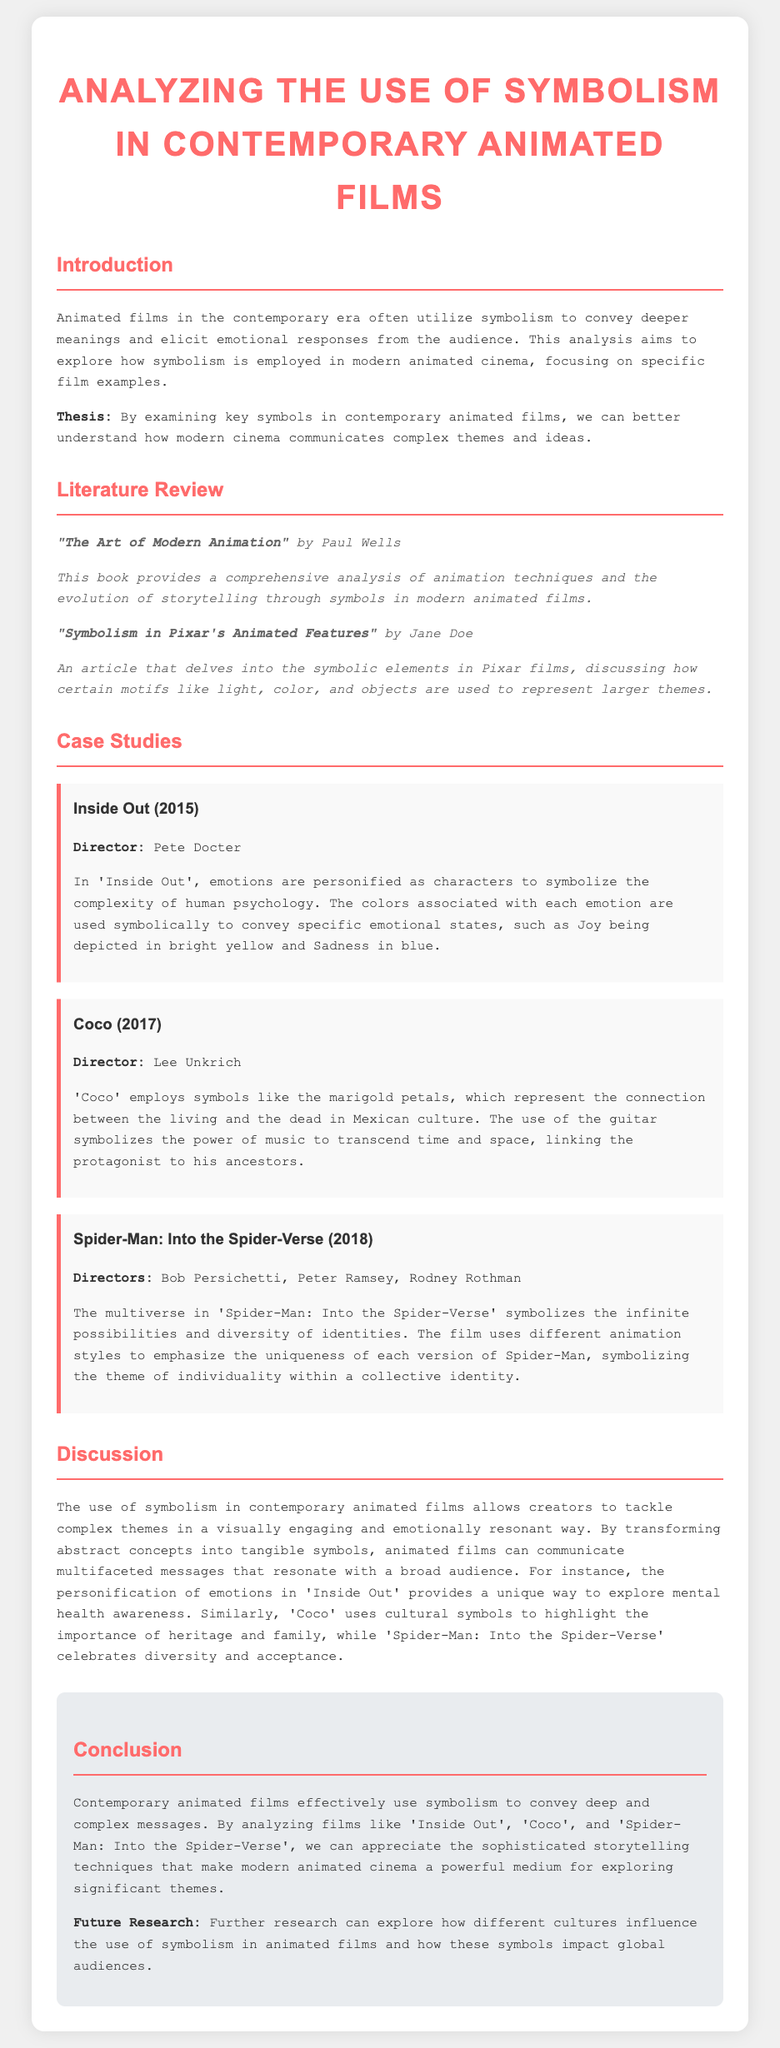What is the title of the report? The title of the report is stated in the document's header, which introduces the main analysis focus.
Answer: Analyzing the Use of Symbolism in Contemporary Animated Films Who is the director of 'Inside Out'? The director's name is mentioned in the case study section detailing the film and its elements.
Answer: Pete Docter What year was 'Coco' released? The release year is included in the specific case study for 'Coco'.
Answer: 2017 What do the marigold petals symbolize in 'Coco'? The document explains that certain symbols in films represent specific cultural meanings.
Answer: Connection between the living and the dead Which two films are compared regarding their exploration of complexity and identity? The discussion section covers the themes tackled by the mentioned films, highlighting similarities in their messaging.
Answer: 'Inside Out' and 'Spider-Man: Into the Spider-Verse' What type of source is "The Art of Modern Animation"? The type of source is identified in the literature review section accompanying the analysis.
Answer: Book What does the multiverse symbolize in 'Spider-Man: Into the Spider-Verse'? The symbolic representation is explained in the case study and describes what the multiverse conveys about identity.
Answer: Infinite possibilities and diversity of identities What is the future research suggestion mentioned in the report? The conclusion provides a direction for future studies that could build on the current analysis presented.
Answer: Influence of different cultures on symbolism in animated films How is 'Inside Out' significant in relation to mental health? The discussion highlights how this film addresses sensitive themes using personified emotions, leading to a deeper understanding.
Answer: Unique way to explore mental health awareness 